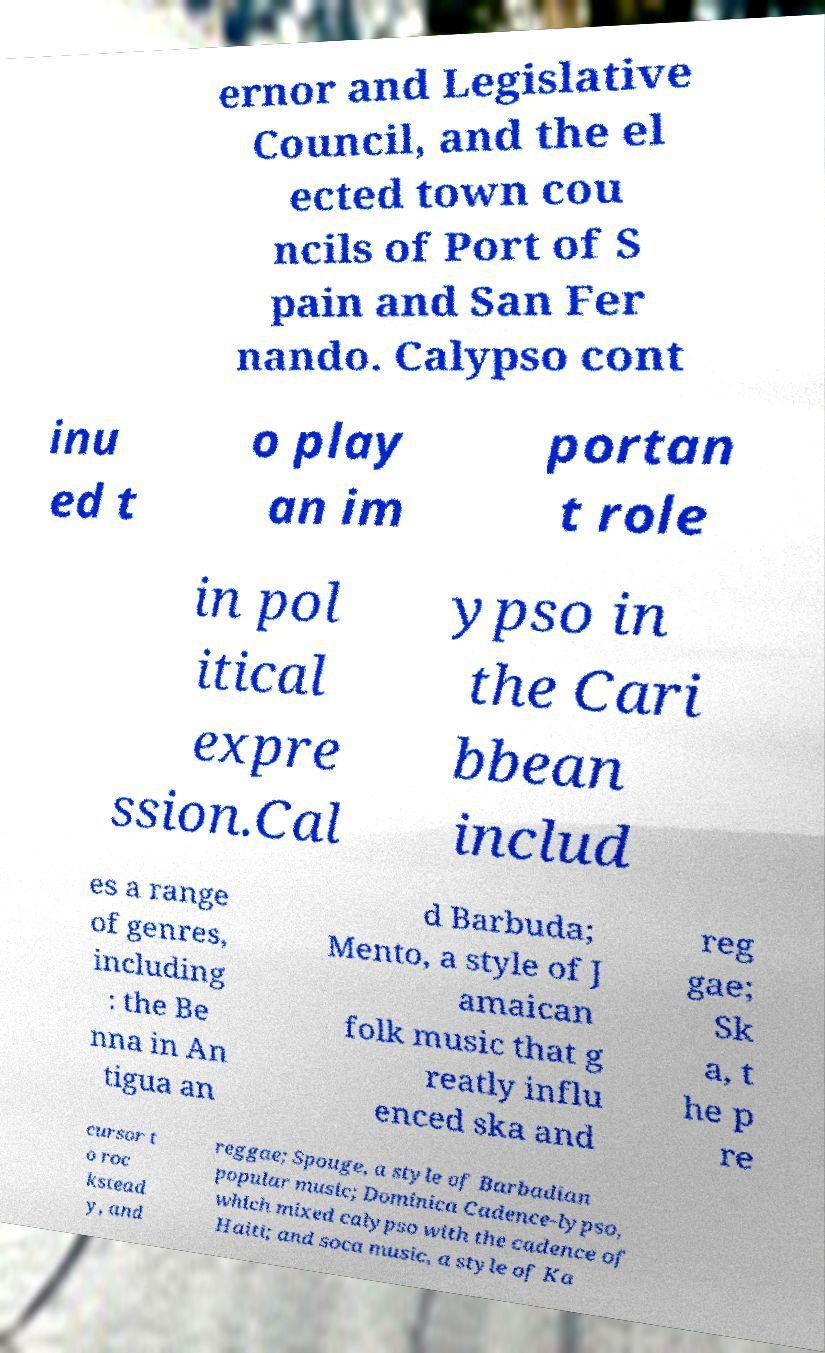I need the written content from this picture converted into text. Can you do that? ernor and Legislative Council, and the el ected town cou ncils of Port of S pain and San Fer nando. Calypso cont inu ed t o play an im portan t role in pol itical expre ssion.Cal ypso in the Cari bbean includ es a range of genres, including : the Be nna in An tigua an d Barbuda; Mento, a style of J amaican folk music that g reatly influ enced ska and reg gae; Sk a, t he p re cursor t o roc kstead y, and reggae; Spouge, a style of Barbadian popular music; Dominica Cadence-lypso, which mixed calypso with the cadence of Haiti; and soca music, a style of Ka 